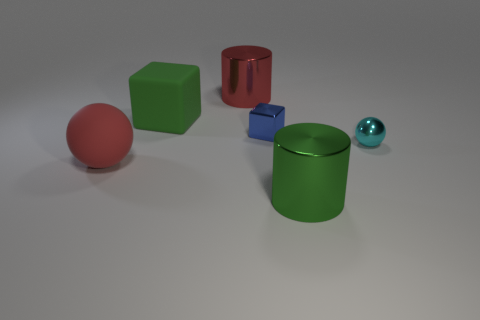How many purple metallic balls are the same size as the cyan object?
Provide a succinct answer. 0. What number of cyan things are either small metallic objects or tiny balls?
Provide a short and direct response. 1. The big thing to the right of the metallic cylinder behind the small cyan object is what shape?
Offer a terse response. Cylinder. What shape is the rubber object that is the same size as the red sphere?
Make the answer very short. Cube. Is there a metal cylinder of the same color as the tiny metal cube?
Your answer should be very brief. No. Is the number of red spheres that are in front of the green cylinder the same as the number of large objects that are in front of the matte block?
Provide a succinct answer. No. There is a red shiny object; is its shape the same as the large matte object that is on the right side of the red ball?
Your response must be concise. No. What number of other things are the same material as the blue thing?
Offer a very short reply. 3. There is a blue metal block; are there any cyan objects to the left of it?
Provide a succinct answer. No. Is the size of the blue object the same as the shiny cylinder behind the small cyan metallic ball?
Make the answer very short. No. 